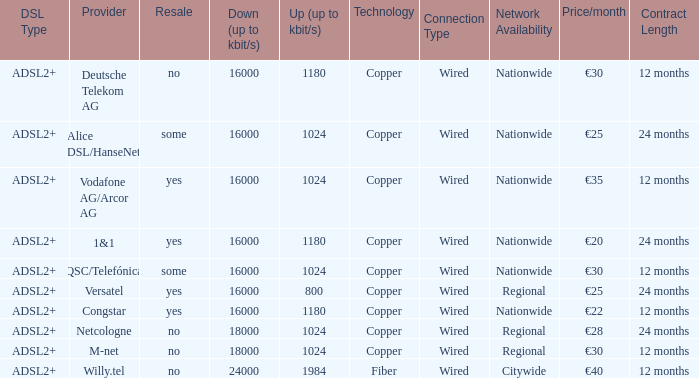What are all the dsl type offered by the M-Net telecom company? ADSL2+. 